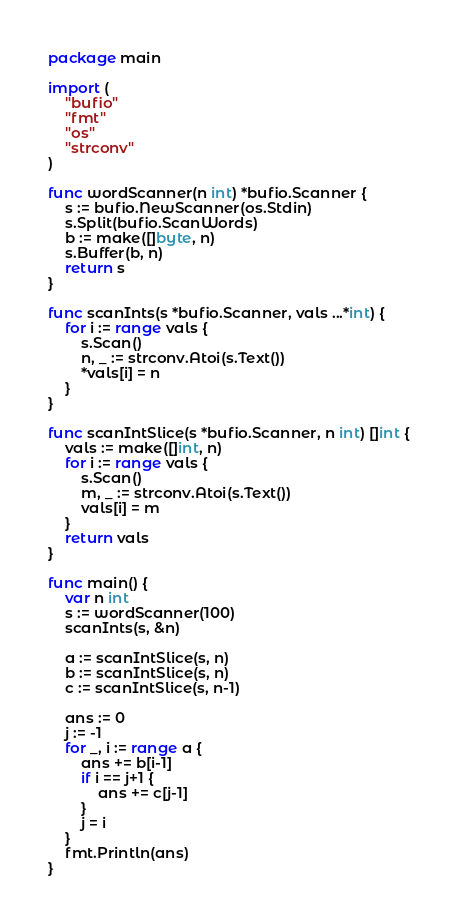<code> <loc_0><loc_0><loc_500><loc_500><_Go_>package main

import (
	"bufio"
	"fmt"
	"os"
	"strconv"
)

func wordScanner(n int) *bufio.Scanner {
	s := bufio.NewScanner(os.Stdin)
	s.Split(bufio.ScanWords)
	b := make([]byte, n)
	s.Buffer(b, n)
	return s
}

func scanInts(s *bufio.Scanner, vals ...*int) {
	for i := range vals {
		s.Scan()
		n, _ := strconv.Atoi(s.Text())
		*vals[i] = n
	}
}

func scanIntSlice(s *bufio.Scanner, n int) []int {
	vals := make([]int, n)
	for i := range vals {
		s.Scan()
		m, _ := strconv.Atoi(s.Text())
		vals[i] = m
	}
	return vals
}

func main() {
	var n int
	s := wordScanner(100)
	scanInts(s, &n)

	a := scanIntSlice(s, n)
	b := scanIntSlice(s, n)
	c := scanIntSlice(s, n-1)

	ans := 0
	j := -1
	for _, i := range a {
		ans += b[i-1]
		if i == j+1 {
			ans += c[j-1]
		}
		j = i
	}
	fmt.Println(ans)
}
</code> 